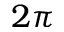Convert formula to latex. <formula><loc_0><loc_0><loc_500><loc_500>2 \pi</formula> 